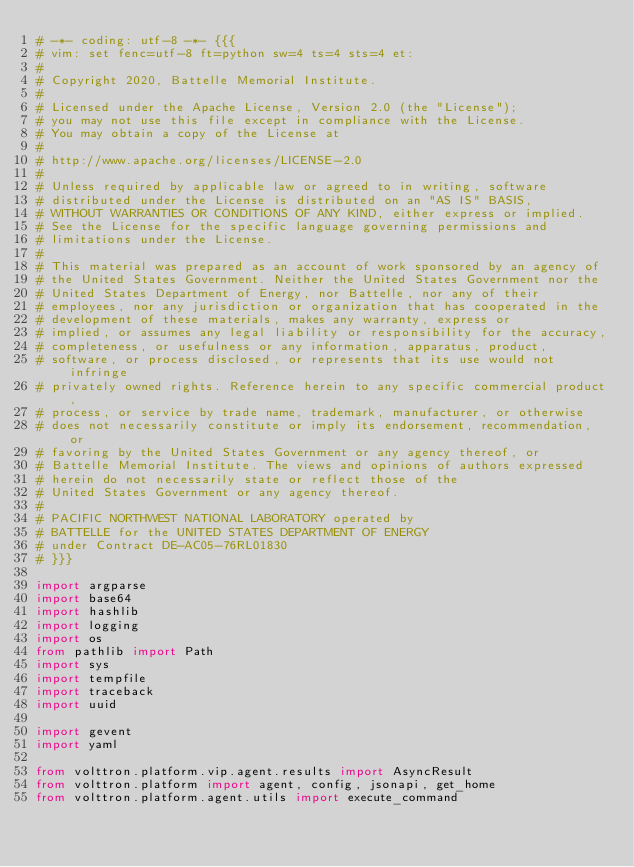Convert code to text. <code><loc_0><loc_0><loc_500><loc_500><_Python_># -*- coding: utf-8 -*- {{{
# vim: set fenc=utf-8 ft=python sw=4 ts=4 sts=4 et:
#
# Copyright 2020, Battelle Memorial Institute.
#
# Licensed under the Apache License, Version 2.0 (the "License");
# you may not use this file except in compliance with the License.
# You may obtain a copy of the License at
#
# http://www.apache.org/licenses/LICENSE-2.0
#
# Unless required by applicable law or agreed to in writing, software
# distributed under the License is distributed on an "AS IS" BASIS,
# WITHOUT WARRANTIES OR CONDITIONS OF ANY KIND, either express or implied.
# See the License for the specific language governing permissions and
# limitations under the License.
#
# This material was prepared as an account of work sponsored by an agency of
# the United States Government. Neither the United States Government nor the
# United States Department of Energy, nor Battelle, nor any of their
# employees, nor any jurisdiction or organization that has cooperated in the
# development of these materials, makes any warranty, express or
# implied, or assumes any legal liability or responsibility for the accuracy,
# completeness, or usefulness or any information, apparatus, product,
# software, or process disclosed, or represents that its use would not infringe
# privately owned rights. Reference herein to any specific commercial product,
# process, or service by trade name, trademark, manufacturer, or otherwise
# does not necessarily constitute or imply its endorsement, recommendation, or
# favoring by the United States Government or any agency thereof, or
# Battelle Memorial Institute. The views and opinions of authors expressed
# herein do not necessarily state or reflect those of the
# United States Government or any agency thereof.
#
# PACIFIC NORTHWEST NATIONAL LABORATORY operated by
# BATTELLE for the UNITED STATES DEPARTMENT OF ENERGY
# under Contract DE-AC05-76RL01830
# }}}

import argparse
import base64
import hashlib
import logging
import os
from pathlib import Path
import sys
import tempfile
import traceback
import uuid

import gevent
import yaml

from volttron.platform.vip.agent.results import AsyncResult
from volttron.platform import agent, config, jsonapi, get_home
from volttron.platform.agent.utils import execute_command</code> 